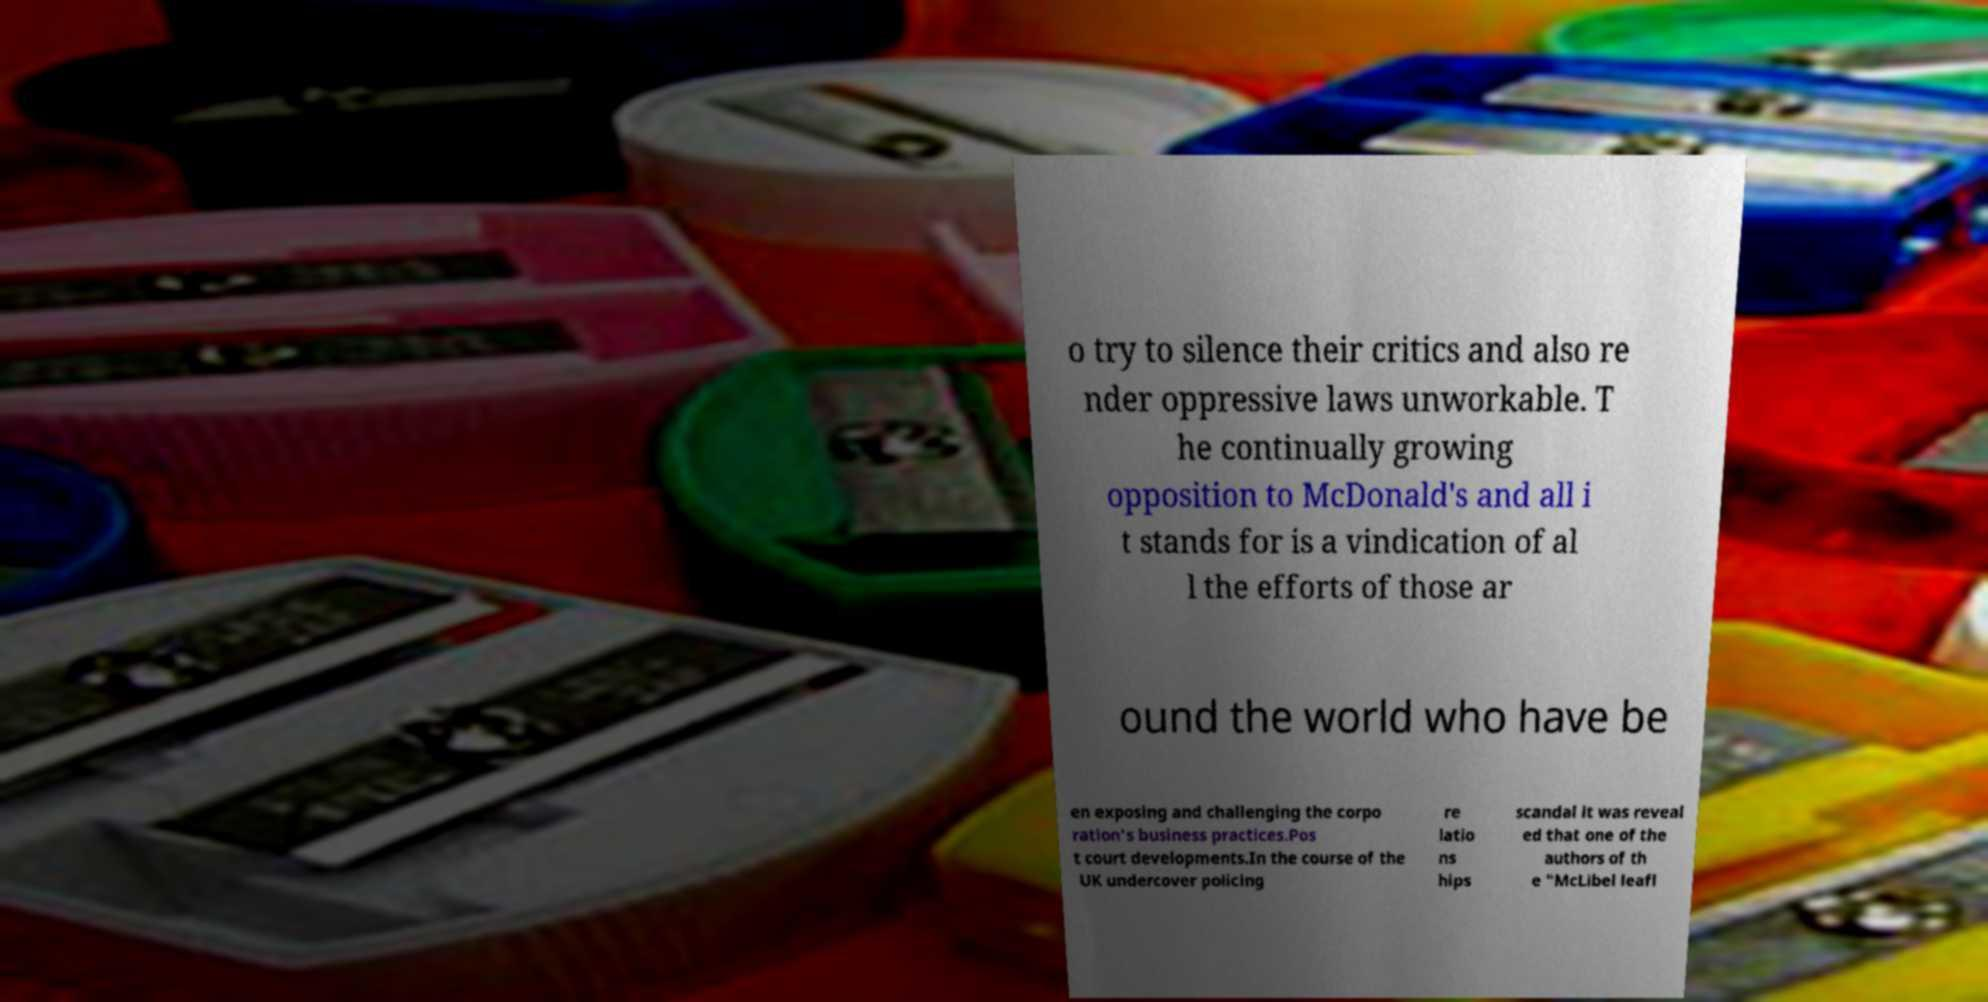For documentation purposes, I need the text within this image transcribed. Could you provide that? o try to silence their critics and also re nder oppressive laws unworkable. T he continually growing opposition to McDonald's and all i t stands for is a vindication of al l the efforts of those ar ound the world who have be en exposing and challenging the corpo ration's business practices.Pos t court developments.In the course of the UK undercover policing re latio ns hips scandal it was reveal ed that one of the authors of th e "McLibel leafl 